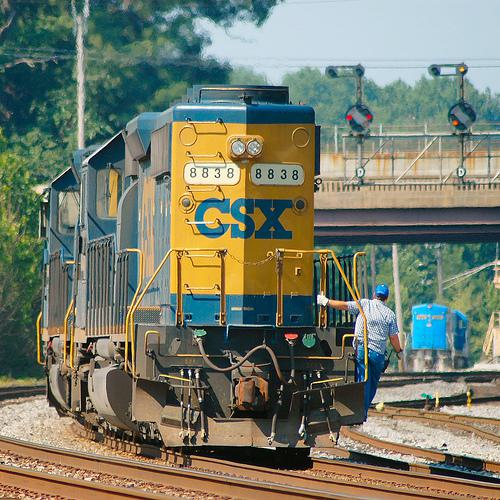What type of environment is the train in? The train is operating in a daytime setting, likely in a semi-urban or industrial area, as indicated by the background infrastructure and the surrounding foliage. 